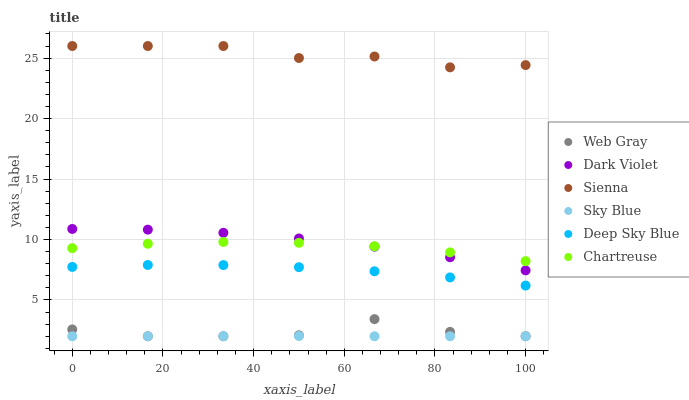Does Sky Blue have the minimum area under the curve?
Answer yes or no. Yes. Does Sienna have the maximum area under the curve?
Answer yes or no. Yes. Does Dark Violet have the minimum area under the curve?
Answer yes or no. No. Does Dark Violet have the maximum area under the curve?
Answer yes or no. No. Is Sky Blue the smoothest?
Answer yes or no. Yes. Is Web Gray the roughest?
Answer yes or no. Yes. Is Dark Violet the smoothest?
Answer yes or no. No. Is Dark Violet the roughest?
Answer yes or no. No. Does Web Gray have the lowest value?
Answer yes or no. Yes. Does Dark Violet have the lowest value?
Answer yes or no. No. Does Sienna have the highest value?
Answer yes or no. Yes. Does Dark Violet have the highest value?
Answer yes or no. No. Is Web Gray less than Chartreuse?
Answer yes or no. Yes. Is Dark Violet greater than Web Gray?
Answer yes or no. Yes. Does Dark Violet intersect Chartreuse?
Answer yes or no. Yes. Is Dark Violet less than Chartreuse?
Answer yes or no. No. Is Dark Violet greater than Chartreuse?
Answer yes or no. No. Does Web Gray intersect Chartreuse?
Answer yes or no. No. 